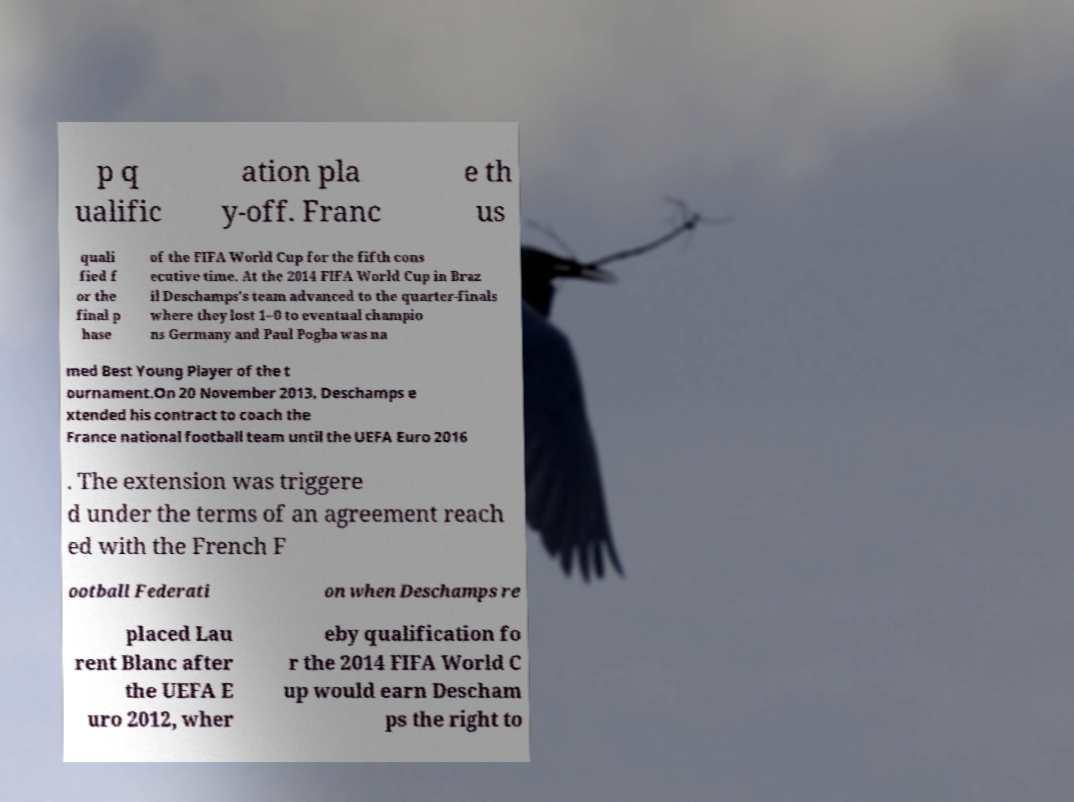Could you assist in decoding the text presented in this image and type it out clearly? p q ualific ation pla y-off. Franc e th us quali fied f or the final p hase of the FIFA World Cup for the fifth cons ecutive time. At the 2014 FIFA World Cup in Braz il Deschamps's team advanced to the quarter-finals where they lost 1–0 to eventual champio ns Germany and Paul Pogba was na med Best Young Player of the t ournament.On 20 November 2013, Deschamps e xtended his contract to coach the France national football team until the UEFA Euro 2016 . The extension was triggere d under the terms of an agreement reach ed with the French F ootball Federati on when Deschamps re placed Lau rent Blanc after the UEFA E uro 2012, wher eby qualification fo r the 2014 FIFA World C up would earn Descham ps the right to 